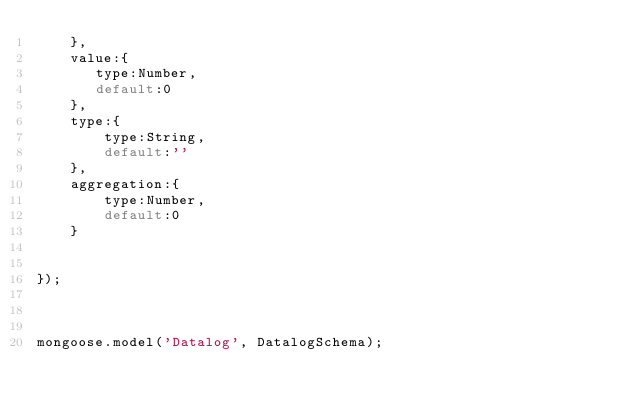<code> <loc_0><loc_0><loc_500><loc_500><_JavaScript_>    },
    value:{
       type:Number,
       default:0
    },
    type:{
        type:String,
        default:''
    },
    aggregation:{
        type:Number,
        default:0
    }


});



mongoose.model('Datalog', DatalogSchema);
</code> 